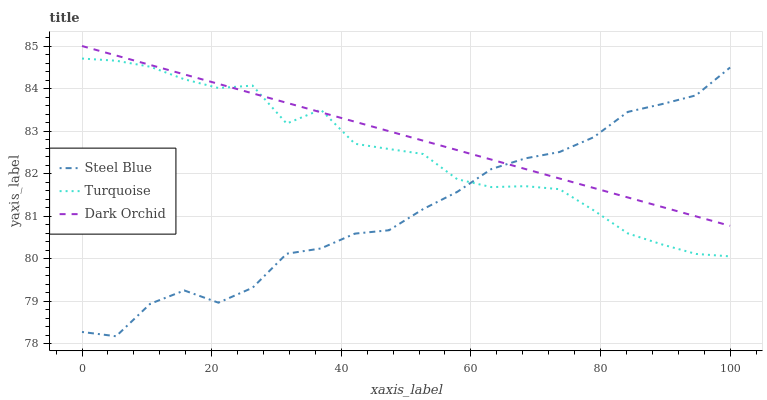Does Steel Blue have the minimum area under the curve?
Answer yes or no. Yes. Does Dark Orchid have the maximum area under the curve?
Answer yes or no. Yes. Does Dark Orchid have the minimum area under the curve?
Answer yes or no. No. Does Steel Blue have the maximum area under the curve?
Answer yes or no. No. Is Dark Orchid the smoothest?
Answer yes or no. Yes. Is Turquoise the roughest?
Answer yes or no. Yes. Is Steel Blue the smoothest?
Answer yes or no. No. Is Steel Blue the roughest?
Answer yes or no. No. Does Steel Blue have the lowest value?
Answer yes or no. Yes. Does Dark Orchid have the lowest value?
Answer yes or no. No. Does Dark Orchid have the highest value?
Answer yes or no. Yes. Does Steel Blue have the highest value?
Answer yes or no. No. Does Dark Orchid intersect Steel Blue?
Answer yes or no. Yes. Is Dark Orchid less than Steel Blue?
Answer yes or no. No. Is Dark Orchid greater than Steel Blue?
Answer yes or no. No. 